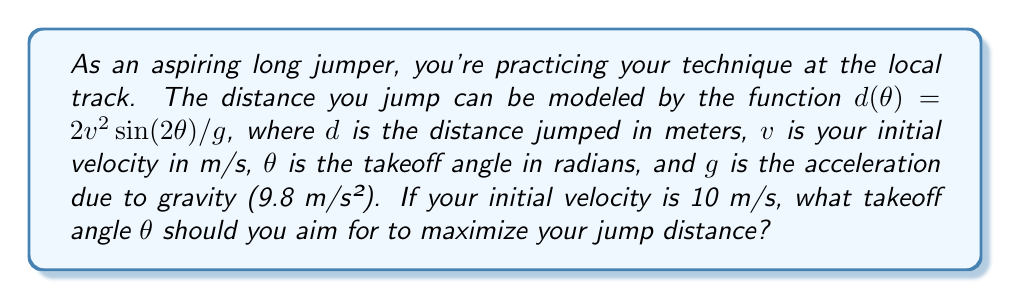Could you help me with this problem? To find the optimal angle, we need to find the maximum of the function $d(\theta)$. We can do this by finding where the derivative $d'(\theta)$ equals zero.

Step 1: Express the function
$$d(\theta) = \frac{2v^2\sin(2\theta)}{g}$$

Step 2: Take the derivative with respect to $\theta$
$$d'(\theta) = \frac{2v^2}{g} \cdot 2\cos(2\theta)$$
$$d'(\theta) = \frac{4v^2}{g}\cos(2\theta)$$

Step 3: Set the derivative equal to zero and solve for $\theta$
$$\frac{4v^2}{g}\cos(2\theta) = 0$$
$$\cos(2\theta) = 0$$
$$2\theta = \frac{\pi}{2}$$
$$\theta = \frac{\pi}{4}$$

Step 4: Verify this is a maximum (not needed for the answer, but good practice)
The second derivative $d''(\theta) = -\frac{8v^2}{g}\sin(2\theta)$ is negative at $\theta = \frac{\pi}{4}$, confirming this is a maximum.

Step 5: Convert radians to degrees
$$\theta = \frac{\pi}{4} \text{ rad} = 45°$$

Therefore, the optimal takeoff angle to maximize jump distance is 45°, regardless of the initial velocity.
Answer: 45° 